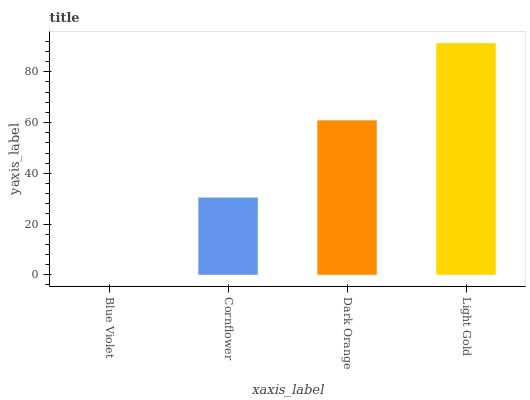Is Blue Violet the minimum?
Answer yes or no. Yes. Is Light Gold the maximum?
Answer yes or no. Yes. Is Cornflower the minimum?
Answer yes or no. No. Is Cornflower the maximum?
Answer yes or no. No. Is Cornflower greater than Blue Violet?
Answer yes or no. Yes. Is Blue Violet less than Cornflower?
Answer yes or no. Yes. Is Blue Violet greater than Cornflower?
Answer yes or no. No. Is Cornflower less than Blue Violet?
Answer yes or no. No. Is Dark Orange the high median?
Answer yes or no. Yes. Is Cornflower the low median?
Answer yes or no. Yes. Is Blue Violet the high median?
Answer yes or no. No. Is Dark Orange the low median?
Answer yes or no. No. 